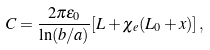<formula> <loc_0><loc_0><loc_500><loc_500>C = \frac { 2 \pi \epsilon _ { 0 } } { \ln ( b / a ) } [ L + \chi _ { e } ( L _ { 0 } + x ) ] \, ,</formula> 